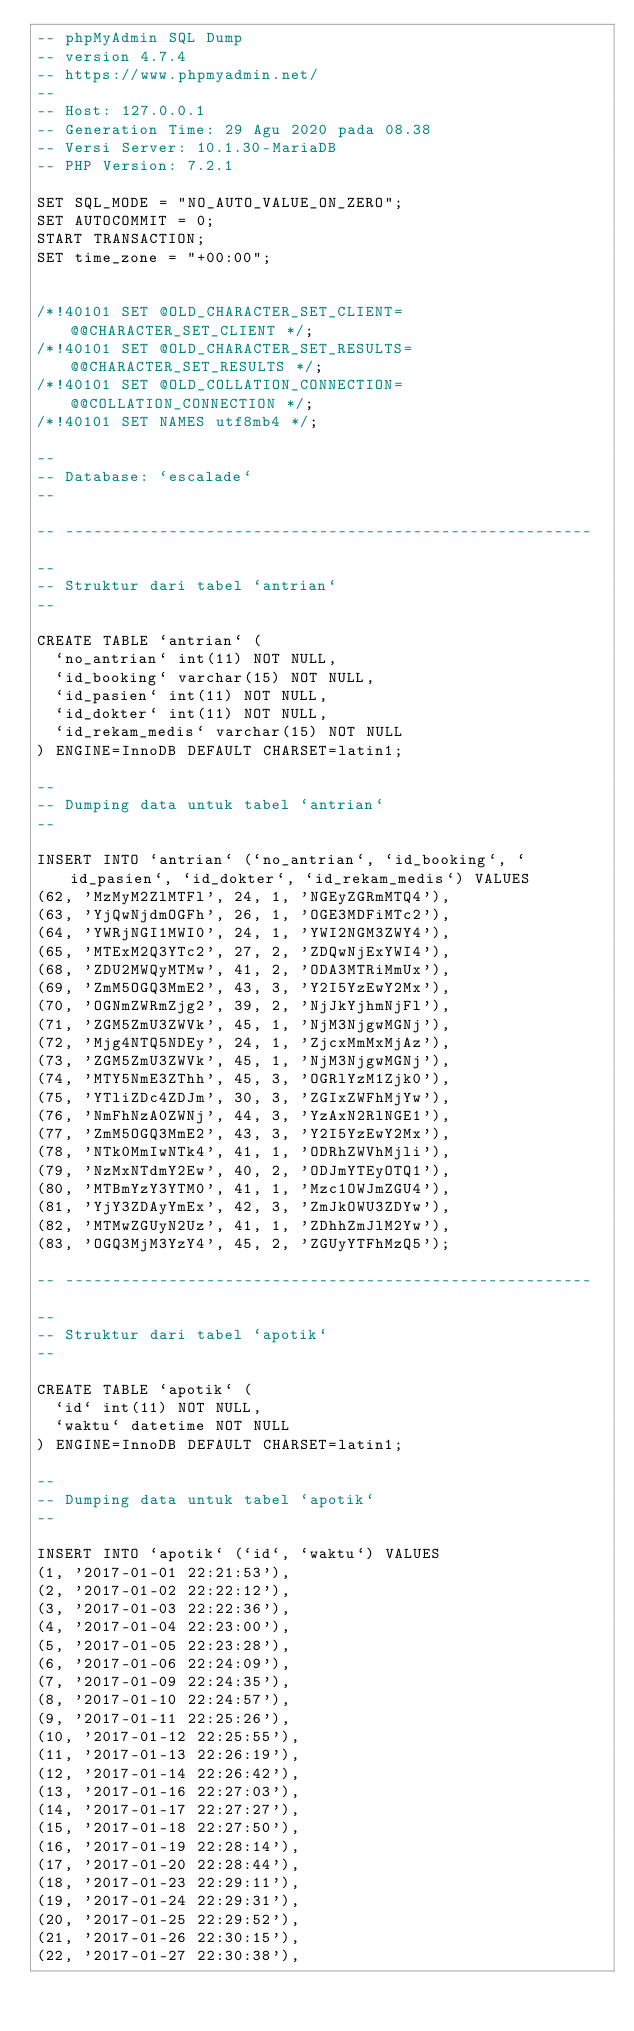<code> <loc_0><loc_0><loc_500><loc_500><_SQL_>-- phpMyAdmin SQL Dump
-- version 4.7.4
-- https://www.phpmyadmin.net/
--
-- Host: 127.0.0.1
-- Generation Time: 29 Agu 2020 pada 08.38
-- Versi Server: 10.1.30-MariaDB
-- PHP Version: 7.2.1

SET SQL_MODE = "NO_AUTO_VALUE_ON_ZERO";
SET AUTOCOMMIT = 0;
START TRANSACTION;
SET time_zone = "+00:00";


/*!40101 SET @OLD_CHARACTER_SET_CLIENT=@@CHARACTER_SET_CLIENT */;
/*!40101 SET @OLD_CHARACTER_SET_RESULTS=@@CHARACTER_SET_RESULTS */;
/*!40101 SET @OLD_COLLATION_CONNECTION=@@COLLATION_CONNECTION */;
/*!40101 SET NAMES utf8mb4 */;

--
-- Database: `escalade`
--

-- --------------------------------------------------------

--
-- Struktur dari tabel `antrian`
--

CREATE TABLE `antrian` (
  `no_antrian` int(11) NOT NULL,
  `id_booking` varchar(15) NOT NULL,
  `id_pasien` int(11) NOT NULL,
  `id_dokter` int(11) NOT NULL,
  `id_rekam_medis` varchar(15) NOT NULL
) ENGINE=InnoDB DEFAULT CHARSET=latin1;

--
-- Dumping data untuk tabel `antrian`
--

INSERT INTO `antrian` (`no_antrian`, `id_booking`, `id_pasien`, `id_dokter`, `id_rekam_medis`) VALUES
(62, 'MzMyM2ZlMTFl', 24, 1, 'NGEyZGRmMTQ4'),
(63, 'YjQwNjdmOGFh', 26, 1, 'OGE3MDFiMTc2'),
(64, 'YWRjNGI1MWI0', 24, 1, 'YWI2NGM3ZWY4'),
(65, 'MTExM2Q3YTc2', 27, 2, 'ZDQwNjExYWI4'),
(68, 'ZDU2MWQyMTMw', 41, 2, 'ODA3MTRiMmUx'),
(69, 'ZmM5OGQ3MmE2', 43, 3, 'Y2I5YzEwY2Mx'),
(70, 'OGNmZWRmZjg2', 39, 2, 'NjJkYjhmNjFl'),
(71, 'ZGM5ZmU3ZWVk', 45, 1, 'NjM3NjgwMGNj'),
(72, 'Mjg4NTQ5NDEy', 24, 1, 'ZjcxMmMxMjAz'),
(73, 'ZGM5ZmU3ZWVk', 45, 1, 'NjM3NjgwMGNj'),
(74, 'MTY5NmE3ZThh', 45, 3, 'OGRlYzM1Zjk0'),
(75, 'YTliZDc4ZDJm', 30, 3, 'ZGIxZWFhMjYw'),
(76, 'NmFhNzA0ZWNj', 44, 3, 'YzAxN2RlNGE1'),
(77, 'ZmM5OGQ3MmE2', 43, 3, 'Y2I5YzEwY2Mx'),
(78, 'NTk0MmIwNTk4', 41, 1, 'ODRhZWVhMjli'),
(79, 'NzMxNTdmY2Ew', 40, 2, 'ODJmYTEyOTQ1'),
(80, 'MTBmYzY3YTM0', 41, 1, 'Mzc1OWJmZGU4'),
(81, 'YjY3ZDAyYmEx', 42, 3, 'ZmJkOWU3ZDYw'),
(82, 'MTMwZGUyN2Uz', 41, 1, 'ZDhhZmJlM2Yw'),
(83, 'OGQ3MjM3YzY4', 45, 2, 'ZGUyYTFhMzQ5');

-- --------------------------------------------------------

--
-- Struktur dari tabel `apotik`
--

CREATE TABLE `apotik` (
  `id` int(11) NOT NULL,
  `waktu` datetime NOT NULL
) ENGINE=InnoDB DEFAULT CHARSET=latin1;

--
-- Dumping data untuk tabel `apotik`
--

INSERT INTO `apotik` (`id`, `waktu`) VALUES
(1, '2017-01-01 22:21:53'),
(2, '2017-01-02 22:22:12'),
(3, '2017-01-03 22:22:36'),
(4, '2017-01-04 22:23:00'),
(5, '2017-01-05 22:23:28'),
(6, '2017-01-06 22:24:09'),
(7, '2017-01-09 22:24:35'),
(8, '2017-01-10 22:24:57'),
(9, '2017-01-11 22:25:26'),
(10, '2017-01-12 22:25:55'),
(11, '2017-01-13 22:26:19'),
(12, '2017-01-14 22:26:42'),
(13, '2017-01-16 22:27:03'),
(14, '2017-01-17 22:27:27'),
(15, '2017-01-18 22:27:50'),
(16, '2017-01-19 22:28:14'),
(17, '2017-01-20 22:28:44'),
(18, '2017-01-23 22:29:11'),
(19, '2017-01-24 22:29:31'),
(20, '2017-01-25 22:29:52'),
(21, '2017-01-26 22:30:15'),
(22, '2017-01-27 22:30:38'),</code> 